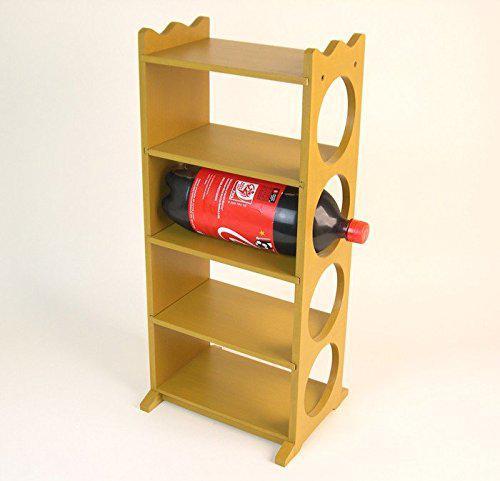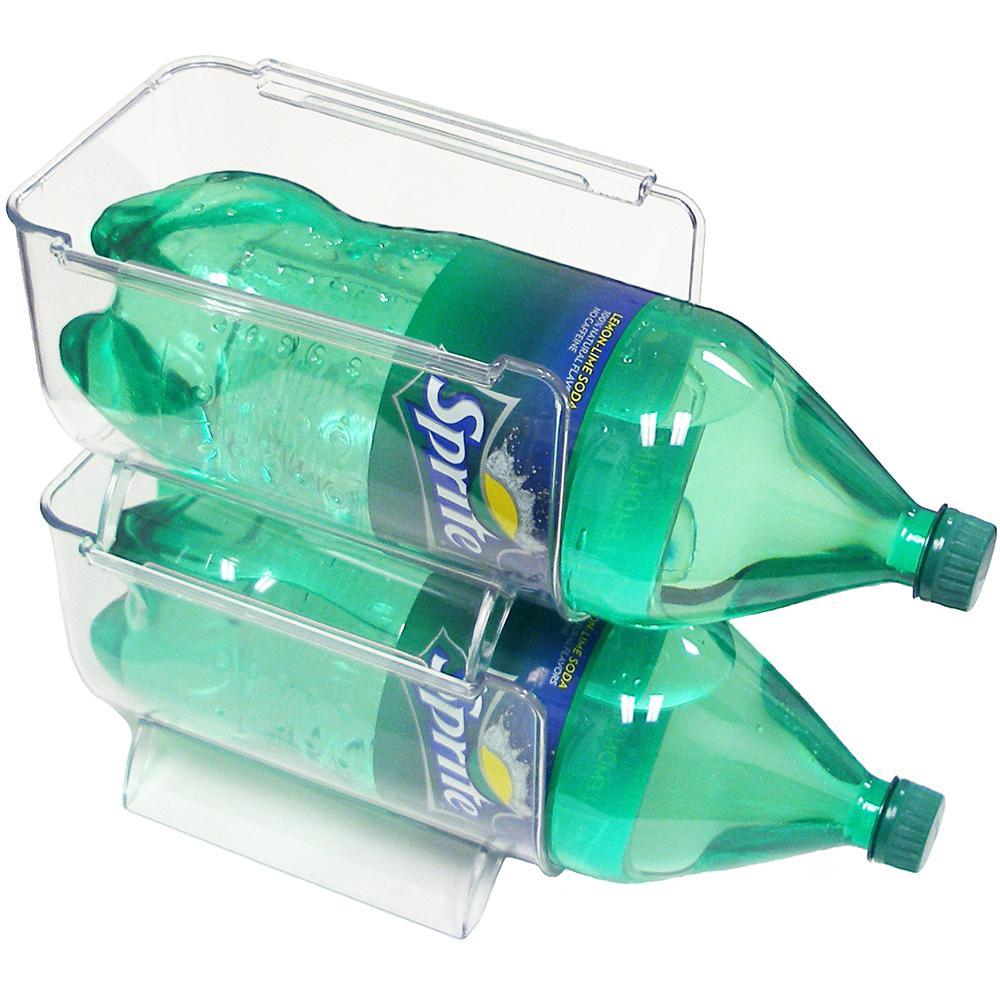The first image is the image on the left, the second image is the image on the right. Assess this claim about the two images: "A person is pouring out the soda in one of the images.". Correct or not? Answer yes or no. No. The first image is the image on the left, the second image is the image on the right. Analyze the images presented: Is the assertion "An image shows one hand gripping a handle attached to a horizontal bottle pouring cola into a glass under it on the left." valid? Answer yes or no. No. 